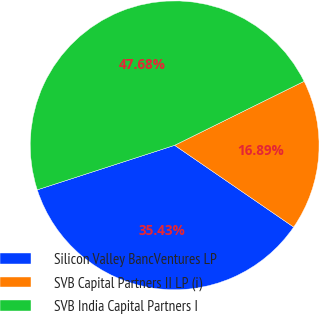Convert chart to OTSL. <chart><loc_0><loc_0><loc_500><loc_500><pie_chart><fcel>Silicon Valley BancVentures LP<fcel>SVB Capital Partners II LP (i)<fcel>SVB India Capital Partners I<nl><fcel>35.43%<fcel>16.89%<fcel>47.68%<nl></chart> 